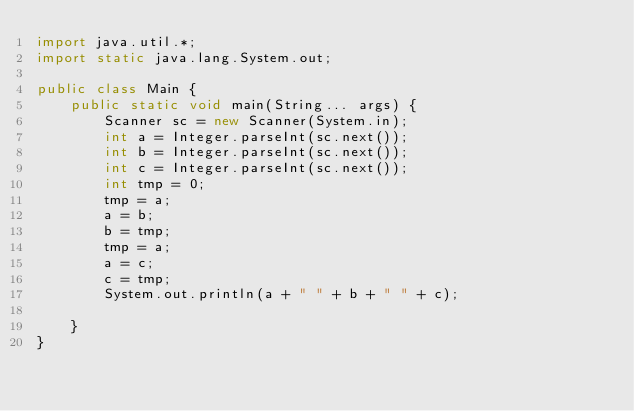<code> <loc_0><loc_0><loc_500><loc_500><_Java_>import java.util.*;
import static java.lang.System.out;

public class Main {
    public static void main(String... args) {
        Scanner sc = new Scanner(System.in);
        int a = Integer.parseInt(sc.next());
        int b = Integer.parseInt(sc.next());
        int c = Integer.parseInt(sc.next());
        int tmp = 0;
        tmp = a;
        a = b;
        b = tmp;
        tmp = a;
        a = c;
        c = tmp;
        System.out.println(a + " " + b + " " + c);

    }
}</code> 